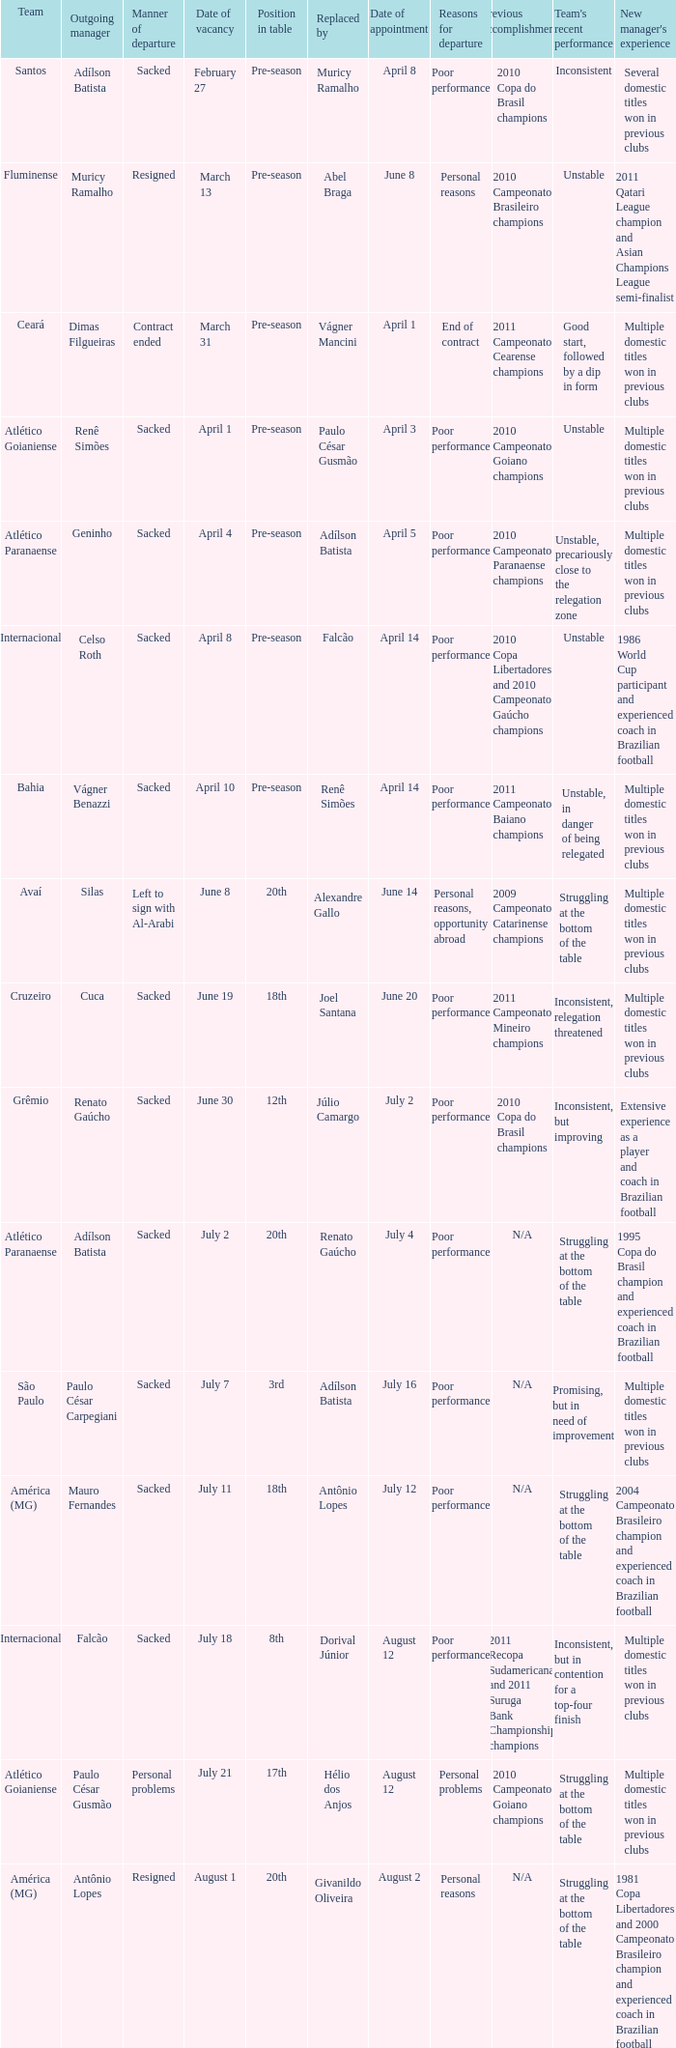Why did Geninho leave as manager? Sacked. 